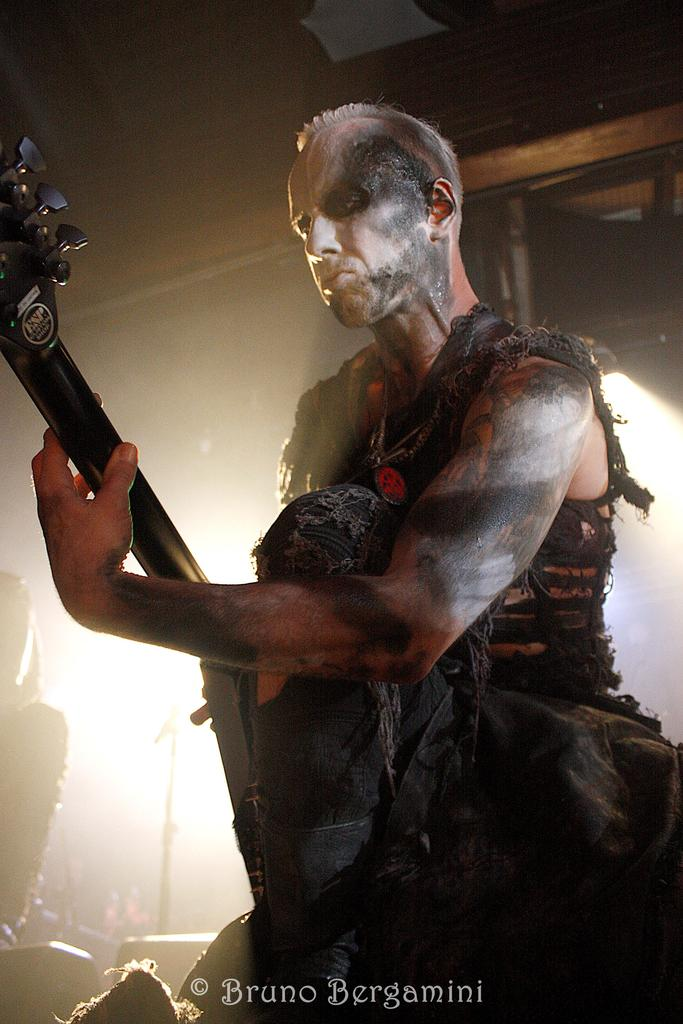What is the person in the image holding? The person is holding a musical instrument in the image. Can you describe the person's clothing? The person is wearing a black dress. What can be seen in the background of the image? There is light visible in the background of the image. Can you see a nest in the image? There is no nest present in the image. 